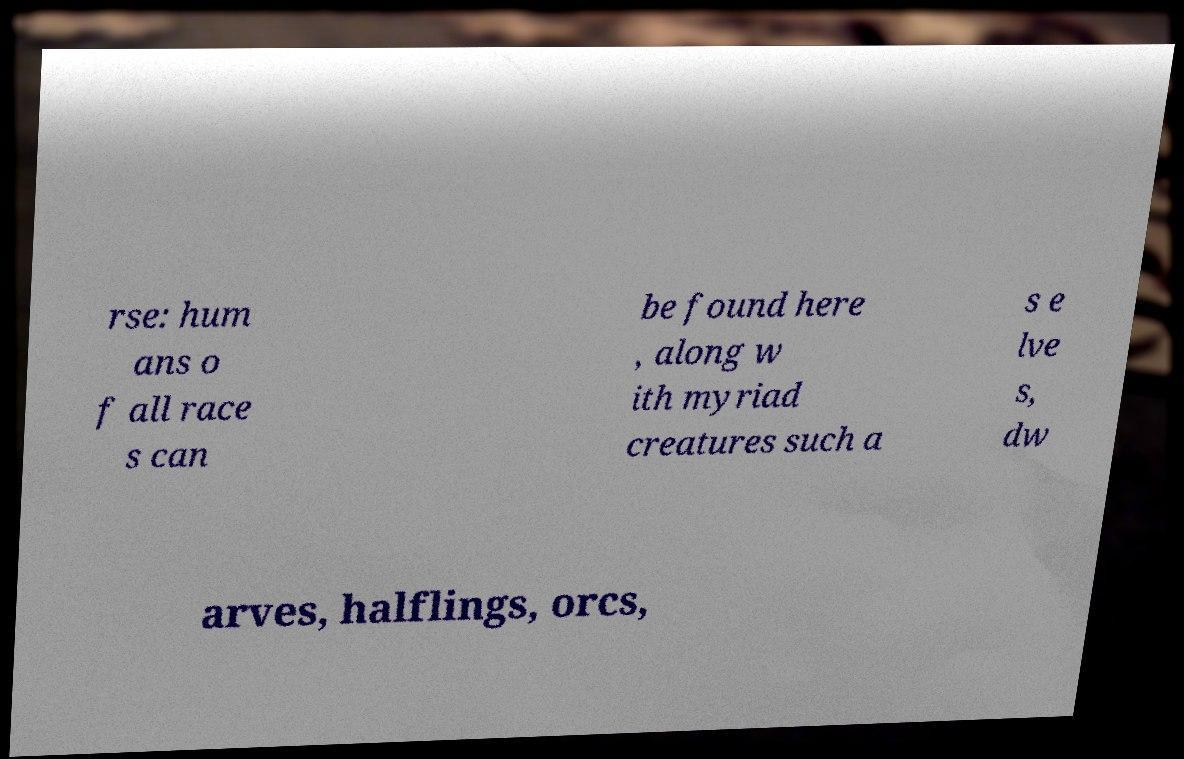For documentation purposes, I need the text within this image transcribed. Could you provide that? rse: hum ans o f all race s can be found here , along w ith myriad creatures such a s e lve s, dw arves, halflings, orcs, 